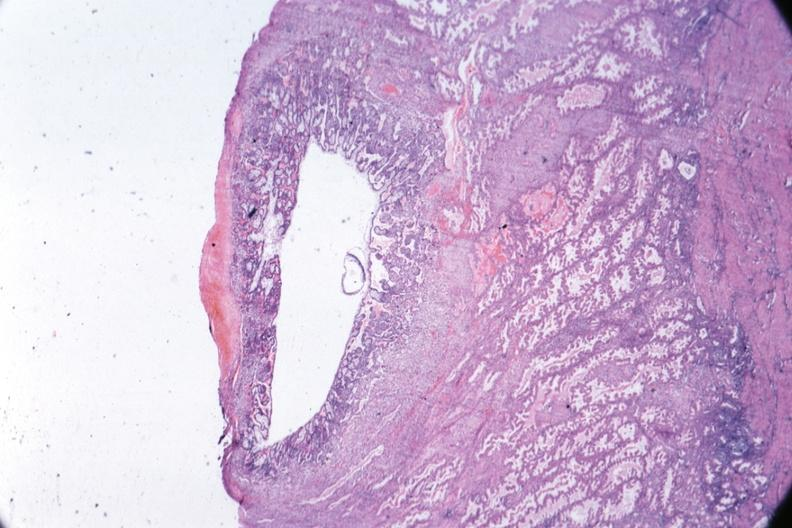s endometrial polyp present?
Answer the question using a single word or phrase. No 